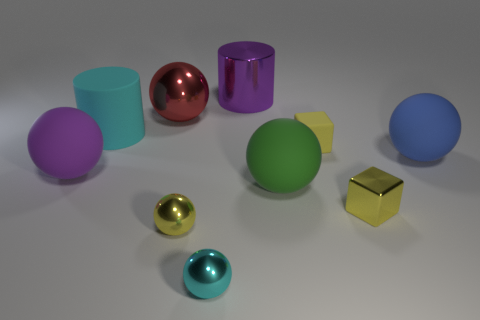There is another block that is the same color as the small shiny block; what material is it?
Provide a short and direct response. Rubber. There is a small metallic object that is to the right of the big purple shiny object; is its shape the same as the large blue thing that is to the right of the cyan cylinder?
Provide a short and direct response. No. How many large matte spheres are right of the tiny cyan thing?
Provide a succinct answer. 2. Are there any red things that have the same material as the large blue thing?
Your answer should be very brief. No. There is a blue sphere that is the same size as the cyan rubber thing; what material is it?
Ensure brevity in your answer.  Rubber. Do the large purple ball and the red object have the same material?
Your response must be concise. No. How many objects are shiny cylinders or green things?
Ensure brevity in your answer.  2. What is the shape of the large metallic thing that is to the right of the tiny cyan metallic ball?
Provide a succinct answer. Cylinder. What color is the small block that is the same material as the purple cylinder?
Make the answer very short. Yellow. What material is the other thing that is the same shape as the small yellow matte object?
Provide a succinct answer. Metal. 